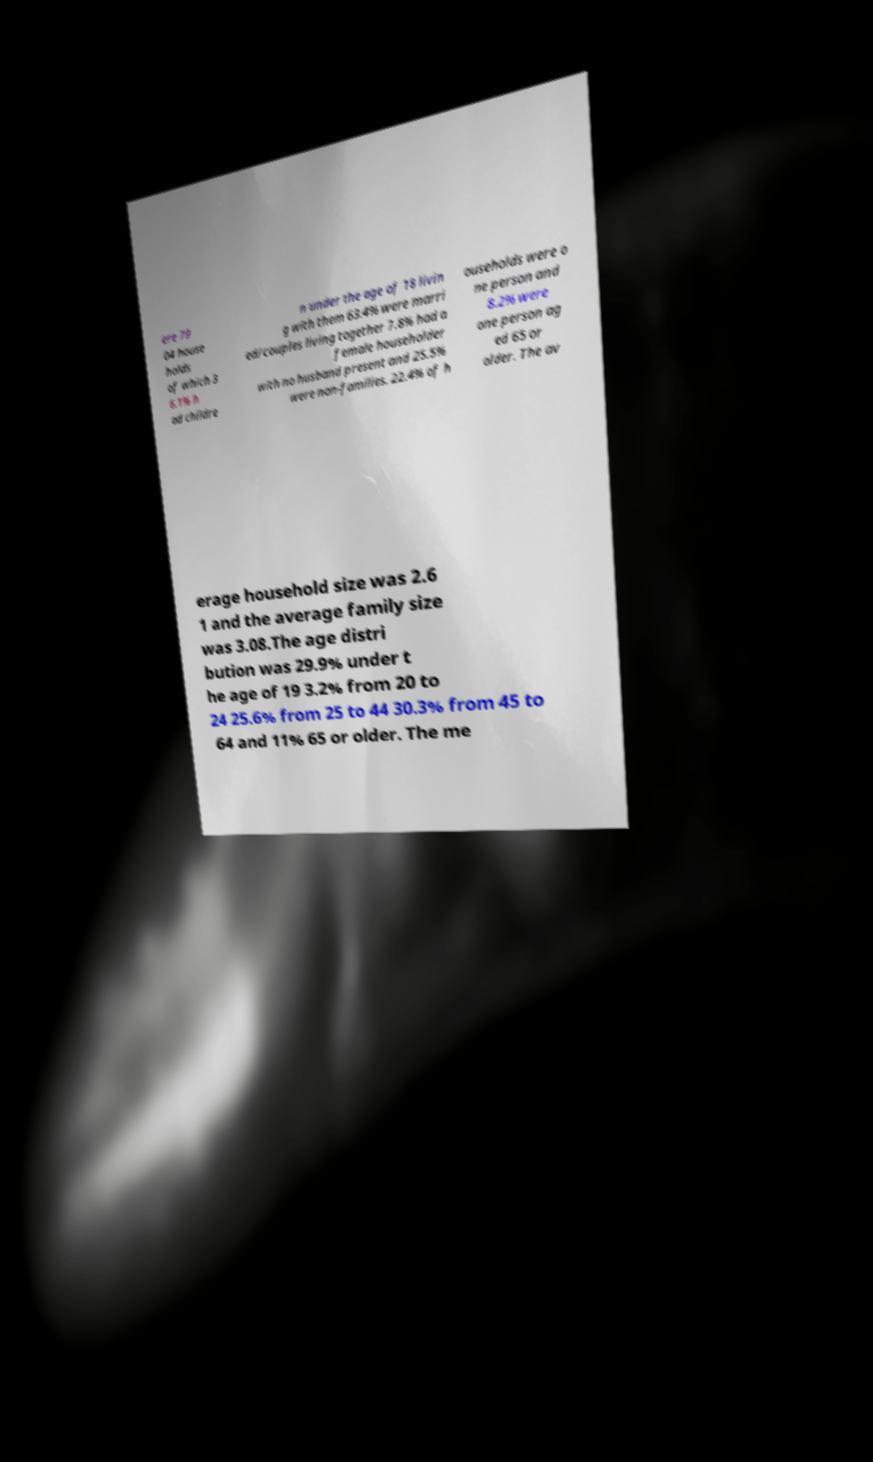What messages or text are displayed in this image? I need them in a readable, typed format. ere 79 04 house holds of which 3 6.1% h ad childre n under the age of 18 livin g with them 63.4% were marri ed/couples living together 7.8% had a female householder with no husband present and 25.5% were non-families. 22.4% of h ouseholds were o ne person and 8.2% were one person ag ed 65 or older. The av erage household size was 2.6 1 and the average family size was 3.08.The age distri bution was 29.9% under t he age of 19 3.2% from 20 to 24 25.6% from 25 to 44 30.3% from 45 to 64 and 11% 65 or older. The me 